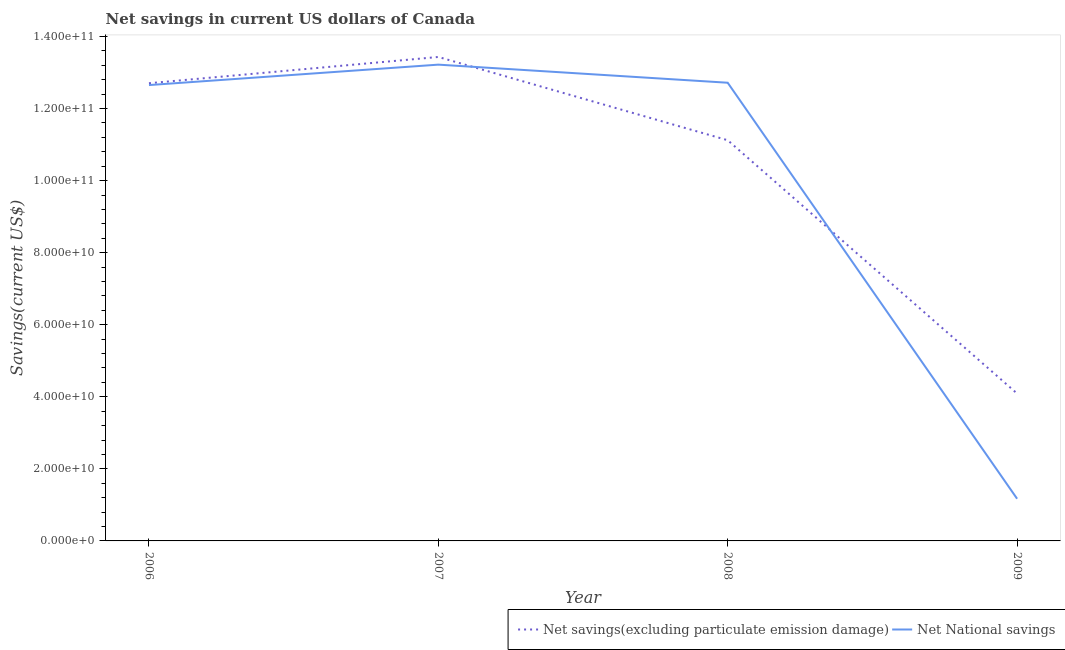Does the line corresponding to net savings(excluding particulate emission damage) intersect with the line corresponding to net national savings?
Your response must be concise. Yes. Is the number of lines equal to the number of legend labels?
Your answer should be compact. Yes. What is the net savings(excluding particulate emission damage) in 2009?
Your response must be concise. 4.09e+1. Across all years, what is the maximum net national savings?
Ensure brevity in your answer.  1.32e+11. Across all years, what is the minimum net savings(excluding particulate emission damage)?
Provide a succinct answer. 4.09e+1. In which year was the net savings(excluding particulate emission damage) minimum?
Your answer should be compact. 2009. What is the total net savings(excluding particulate emission damage) in the graph?
Your response must be concise. 4.13e+11. What is the difference between the net savings(excluding particulate emission damage) in 2006 and that in 2009?
Offer a terse response. 8.61e+1. What is the difference between the net national savings in 2006 and the net savings(excluding particulate emission damage) in 2008?
Ensure brevity in your answer.  1.53e+1. What is the average net savings(excluding particulate emission damage) per year?
Your answer should be very brief. 1.03e+11. In the year 2007, what is the difference between the net savings(excluding particulate emission damage) and net national savings?
Provide a short and direct response. 2.13e+09. What is the ratio of the net national savings in 2007 to that in 2009?
Ensure brevity in your answer.  11.29. Is the net savings(excluding particulate emission damage) in 2007 less than that in 2009?
Offer a very short reply. No. What is the difference between the highest and the second highest net national savings?
Your answer should be very brief. 5.02e+09. What is the difference between the highest and the lowest net national savings?
Ensure brevity in your answer.  1.20e+11. Is the sum of the net national savings in 2007 and 2009 greater than the maximum net savings(excluding particulate emission damage) across all years?
Ensure brevity in your answer.  Yes. Does the net savings(excluding particulate emission damage) monotonically increase over the years?
Your response must be concise. No. Is the net savings(excluding particulate emission damage) strictly greater than the net national savings over the years?
Keep it short and to the point. No. What is the difference between two consecutive major ticks on the Y-axis?
Your answer should be very brief. 2.00e+1. Are the values on the major ticks of Y-axis written in scientific E-notation?
Offer a very short reply. Yes. Does the graph contain grids?
Make the answer very short. No. Where does the legend appear in the graph?
Ensure brevity in your answer.  Bottom right. How many legend labels are there?
Provide a short and direct response. 2. How are the legend labels stacked?
Make the answer very short. Horizontal. What is the title of the graph?
Offer a terse response. Net savings in current US dollars of Canada. What is the label or title of the Y-axis?
Offer a very short reply. Savings(current US$). What is the Savings(current US$) of Net savings(excluding particulate emission damage) in 2006?
Provide a short and direct response. 1.27e+11. What is the Savings(current US$) of Net National savings in 2006?
Ensure brevity in your answer.  1.27e+11. What is the Savings(current US$) of Net savings(excluding particulate emission damage) in 2007?
Your answer should be very brief. 1.34e+11. What is the Savings(current US$) of Net National savings in 2007?
Ensure brevity in your answer.  1.32e+11. What is the Savings(current US$) in Net savings(excluding particulate emission damage) in 2008?
Your answer should be compact. 1.11e+11. What is the Savings(current US$) of Net National savings in 2008?
Offer a very short reply. 1.27e+11. What is the Savings(current US$) in Net savings(excluding particulate emission damage) in 2009?
Provide a succinct answer. 4.09e+1. What is the Savings(current US$) of Net National savings in 2009?
Ensure brevity in your answer.  1.17e+1. Across all years, what is the maximum Savings(current US$) of Net savings(excluding particulate emission damage)?
Provide a succinct answer. 1.34e+11. Across all years, what is the maximum Savings(current US$) of Net National savings?
Your answer should be very brief. 1.32e+11. Across all years, what is the minimum Savings(current US$) in Net savings(excluding particulate emission damage)?
Offer a terse response. 4.09e+1. Across all years, what is the minimum Savings(current US$) of Net National savings?
Keep it short and to the point. 1.17e+1. What is the total Savings(current US$) of Net savings(excluding particulate emission damage) in the graph?
Offer a terse response. 4.13e+11. What is the total Savings(current US$) of Net National savings in the graph?
Keep it short and to the point. 3.98e+11. What is the difference between the Savings(current US$) of Net savings(excluding particulate emission damage) in 2006 and that in 2007?
Offer a very short reply. -7.29e+09. What is the difference between the Savings(current US$) in Net National savings in 2006 and that in 2007?
Provide a short and direct response. -5.67e+09. What is the difference between the Savings(current US$) in Net savings(excluding particulate emission damage) in 2006 and that in 2008?
Offer a very short reply. 1.58e+1. What is the difference between the Savings(current US$) in Net National savings in 2006 and that in 2008?
Give a very brief answer. -6.46e+08. What is the difference between the Savings(current US$) in Net savings(excluding particulate emission damage) in 2006 and that in 2009?
Make the answer very short. 8.61e+1. What is the difference between the Savings(current US$) in Net National savings in 2006 and that in 2009?
Your answer should be compact. 1.15e+11. What is the difference between the Savings(current US$) of Net savings(excluding particulate emission damage) in 2007 and that in 2008?
Your answer should be compact. 2.31e+1. What is the difference between the Savings(current US$) of Net National savings in 2007 and that in 2008?
Provide a short and direct response. 5.02e+09. What is the difference between the Savings(current US$) in Net savings(excluding particulate emission damage) in 2007 and that in 2009?
Your answer should be compact. 9.34e+1. What is the difference between the Savings(current US$) of Net National savings in 2007 and that in 2009?
Provide a short and direct response. 1.20e+11. What is the difference between the Savings(current US$) of Net savings(excluding particulate emission damage) in 2008 and that in 2009?
Your response must be concise. 7.03e+1. What is the difference between the Savings(current US$) in Net National savings in 2008 and that in 2009?
Ensure brevity in your answer.  1.15e+11. What is the difference between the Savings(current US$) of Net savings(excluding particulate emission damage) in 2006 and the Savings(current US$) of Net National savings in 2007?
Provide a short and direct response. -5.16e+09. What is the difference between the Savings(current US$) of Net savings(excluding particulate emission damage) in 2006 and the Savings(current US$) of Net National savings in 2008?
Your response must be concise. -1.37e+08. What is the difference between the Savings(current US$) in Net savings(excluding particulate emission damage) in 2006 and the Savings(current US$) in Net National savings in 2009?
Your answer should be very brief. 1.15e+11. What is the difference between the Savings(current US$) in Net savings(excluding particulate emission damage) in 2007 and the Savings(current US$) in Net National savings in 2008?
Provide a succinct answer. 7.15e+09. What is the difference between the Savings(current US$) in Net savings(excluding particulate emission damage) in 2007 and the Savings(current US$) in Net National savings in 2009?
Your answer should be compact. 1.23e+11. What is the difference between the Savings(current US$) of Net savings(excluding particulate emission damage) in 2008 and the Savings(current US$) of Net National savings in 2009?
Ensure brevity in your answer.  9.95e+1. What is the average Savings(current US$) of Net savings(excluding particulate emission damage) per year?
Your answer should be compact. 1.03e+11. What is the average Savings(current US$) in Net National savings per year?
Make the answer very short. 9.94e+1. In the year 2006, what is the difference between the Savings(current US$) in Net savings(excluding particulate emission damage) and Savings(current US$) in Net National savings?
Make the answer very short. 5.10e+08. In the year 2007, what is the difference between the Savings(current US$) in Net savings(excluding particulate emission damage) and Savings(current US$) in Net National savings?
Your answer should be compact. 2.13e+09. In the year 2008, what is the difference between the Savings(current US$) in Net savings(excluding particulate emission damage) and Savings(current US$) in Net National savings?
Provide a succinct answer. -1.60e+1. In the year 2009, what is the difference between the Savings(current US$) in Net savings(excluding particulate emission damage) and Savings(current US$) in Net National savings?
Offer a very short reply. 2.92e+1. What is the ratio of the Savings(current US$) of Net savings(excluding particulate emission damage) in 2006 to that in 2007?
Make the answer very short. 0.95. What is the ratio of the Savings(current US$) in Net National savings in 2006 to that in 2007?
Offer a terse response. 0.96. What is the ratio of the Savings(current US$) in Net savings(excluding particulate emission damage) in 2006 to that in 2008?
Keep it short and to the point. 1.14. What is the ratio of the Savings(current US$) of Net National savings in 2006 to that in 2008?
Make the answer very short. 0.99. What is the ratio of the Savings(current US$) in Net savings(excluding particulate emission damage) in 2006 to that in 2009?
Keep it short and to the point. 3.11. What is the ratio of the Savings(current US$) in Net National savings in 2006 to that in 2009?
Offer a very short reply. 10.81. What is the ratio of the Savings(current US$) in Net savings(excluding particulate emission damage) in 2007 to that in 2008?
Offer a terse response. 1.21. What is the ratio of the Savings(current US$) of Net National savings in 2007 to that in 2008?
Your answer should be very brief. 1.04. What is the ratio of the Savings(current US$) in Net savings(excluding particulate emission damage) in 2007 to that in 2009?
Offer a terse response. 3.28. What is the ratio of the Savings(current US$) in Net National savings in 2007 to that in 2009?
Your response must be concise. 11.29. What is the ratio of the Savings(current US$) in Net savings(excluding particulate emission damage) in 2008 to that in 2009?
Offer a very short reply. 2.72. What is the ratio of the Savings(current US$) of Net National savings in 2008 to that in 2009?
Make the answer very short. 10.86. What is the difference between the highest and the second highest Savings(current US$) of Net savings(excluding particulate emission damage)?
Provide a short and direct response. 7.29e+09. What is the difference between the highest and the second highest Savings(current US$) of Net National savings?
Provide a succinct answer. 5.02e+09. What is the difference between the highest and the lowest Savings(current US$) in Net savings(excluding particulate emission damage)?
Make the answer very short. 9.34e+1. What is the difference between the highest and the lowest Savings(current US$) of Net National savings?
Your response must be concise. 1.20e+11. 